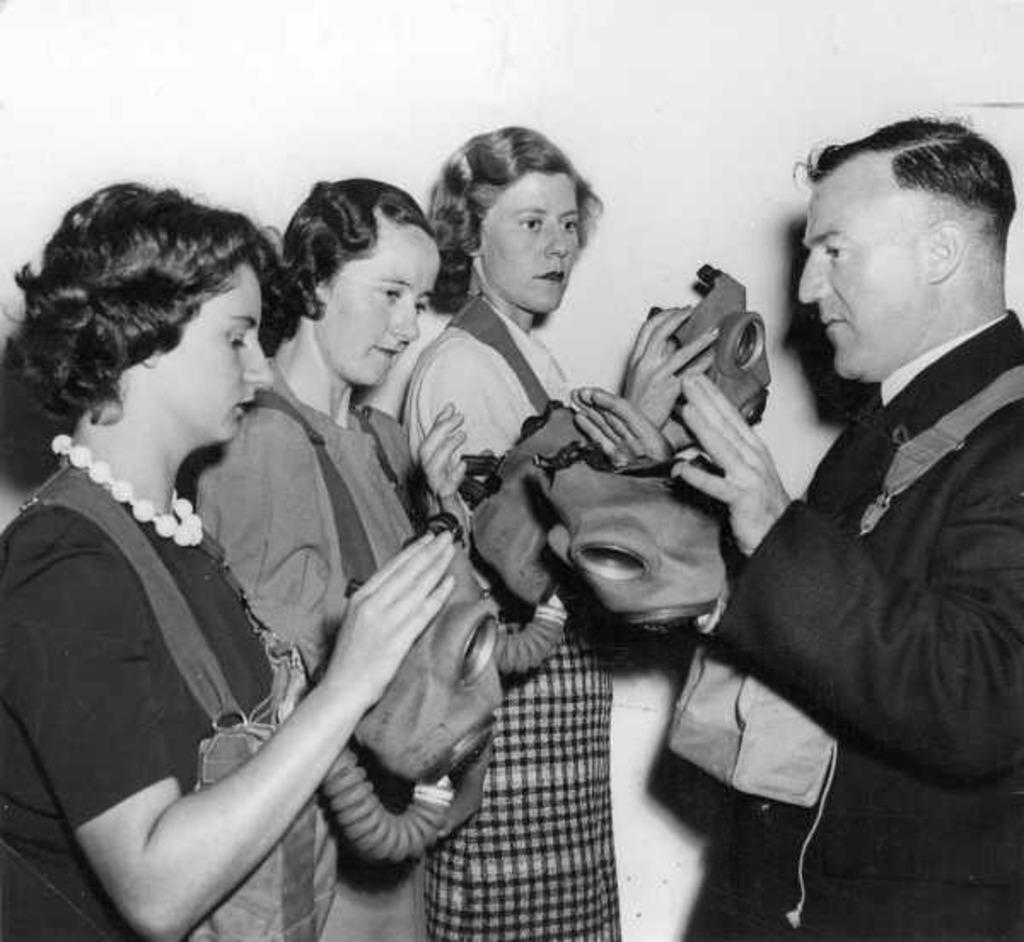Who or what can be seen in the image? There are people in the image. What are the people doing in the image? The people are holding objects in their hands. What is the background of the image? There is a wall in the image. Can you see a comb being used in the image? There is no comb visible in the image. 